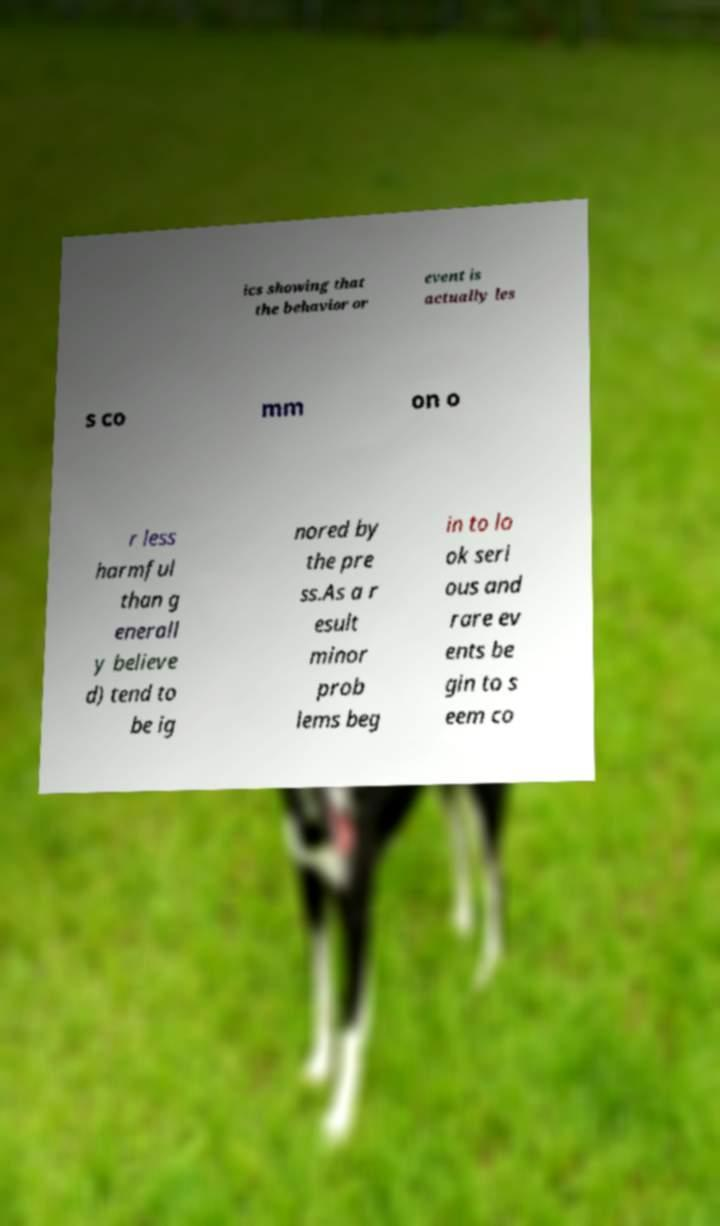Can you accurately transcribe the text from the provided image for me? ics showing that the behavior or event is actually les s co mm on o r less harmful than g enerall y believe d) tend to be ig nored by the pre ss.As a r esult minor prob lems beg in to lo ok seri ous and rare ev ents be gin to s eem co 